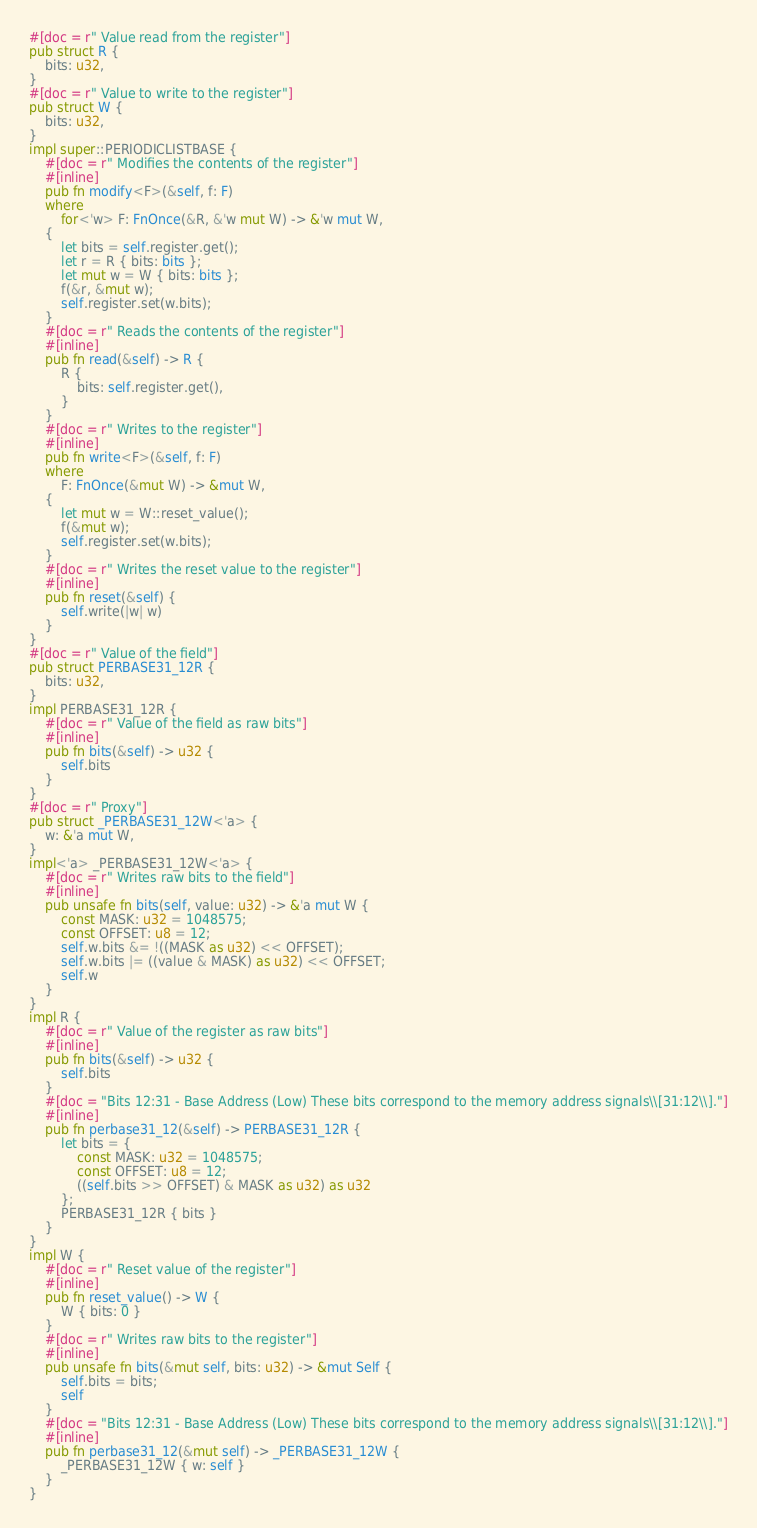Convert code to text. <code><loc_0><loc_0><loc_500><loc_500><_Rust_>#[doc = r" Value read from the register"]
pub struct R {
    bits: u32,
}
#[doc = r" Value to write to the register"]
pub struct W {
    bits: u32,
}
impl super::PERIODICLISTBASE {
    #[doc = r" Modifies the contents of the register"]
    #[inline]
    pub fn modify<F>(&self, f: F)
    where
        for<'w> F: FnOnce(&R, &'w mut W) -> &'w mut W,
    {
        let bits = self.register.get();
        let r = R { bits: bits };
        let mut w = W { bits: bits };
        f(&r, &mut w);
        self.register.set(w.bits);
    }
    #[doc = r" Reads the contents of the register"]
    #[inline]
    pub fn read(&self) -> R {
        R {
            bits: self.register.get(),
        }
    }
    #[doc = r" Writes to the register"]
    #[inline]
    pub fn write<F>(&self, f: F)
    where
        F: FnOnce(&mut W) -> &mut W,
    {
        let mut w = W::reset_value();
        f(&mut w);
        self.register.set(w.bits);
    }
    #[doc = r" Writes the reset value to the register"]
    #[inline]
    pub fn reset(&self) {
        self.write(|w| w)
    }
}
#[doc = r" Value of the field"]
pub struct PERBASE31_12R {
    bits: u32,
}
impl PERBASE31_12R {
    #[doc = r" Value of the field as raw bits"]
    #[inline]
    pub fn bits(&self) -> u32 {
        self.bits
    }
}
#[doc = r" Proxy"]
pub struct _PERBASE31_12W<'a> {
    w: &'a mut W,
}
impl<'a> _PERBASE31_12W<'a> {
    #[doc = r" Writes raw bits to the field"]
    #[inline]
    pub unsafe fn bits(self, value: u32) -> &'a mut W {
        const MASK: u32 = 1048575;
        const OFFSET: u8 = 12;
        self.w.bits &= !((MASK as u32) << OFFSET);
        self.w.bits |= ((value & MASK) as u32) << OFFSET;
        self.w
    }
}
impl R {
    #[doc = r" Value of the register as raw bits"]
    #[inline]
    pub fn bits(&self) -> u32 {
        self.bits
    }
    #[doc = "Bits 12:31 - Base Address (Low) These bits correspond to the memory address signals\\[31:12\\]."]
    #[inline]
    pub fn perbase31_12(&self) -> PERBASE31_12R {
        let bits = {
            const MASK: u32 = 1048575;
            const OFFSET: u8 = 12;
            ((self.bits >> OFFSET) & MASK as u32) as u32
        };
        PERBASE31_12R { bits }
    }
}
impl W {
    #[doc = r" Reset value of the register"]
    #[inline]
    pub fn reset_value() -> W {
        W { bits: 0 }
    }
    #[doc = r" Writes raw bits to the register"]
    #[inline]
    pub unsafe fn bits(&mut self, bits: u32) -> &mut Self {
        self.bits = bits;
        self
    }
    #[doc = "Bits 12:31 - Base Address (Low) These bits correspond to the memory address signals\\[31:12\\]."]
    #[inline]
    pub fn perbase31_12(&mut self) -> _PERBASE31_12W {
        _PERBASE31_12W { w: self }
    }
}
</code> 